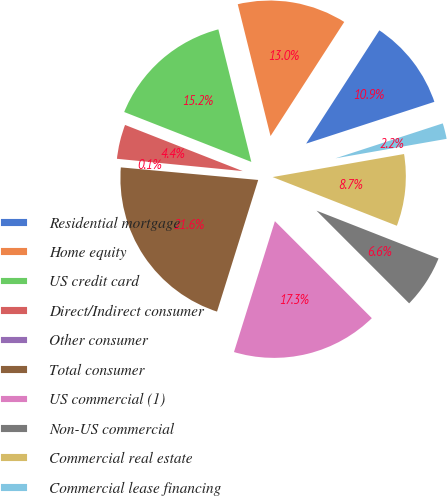Convert chart. <chart><loc_0><loc_0><loc_500><loc_500><pie_chart><fcel>Residential mortgage<fcel>Home equity<fcel>US credit card<fcel>Direct/Indirect consumer<fcel>Other consumer<fcel>Total consumer<fcel>US commercial (1)<fcel>Non-US commercial<fcel>Commercial real estate<fcel>Commercial lease financing<nl><fcel>10.86%<fcel>13.01%<fcel>15.17%<fcel>4.4%<fcel>0.1%<fcel>21.63%<fcel>17.32%<fcel>6.56%<fcel>8.71%<fcel>2.25%<nl></chart> 